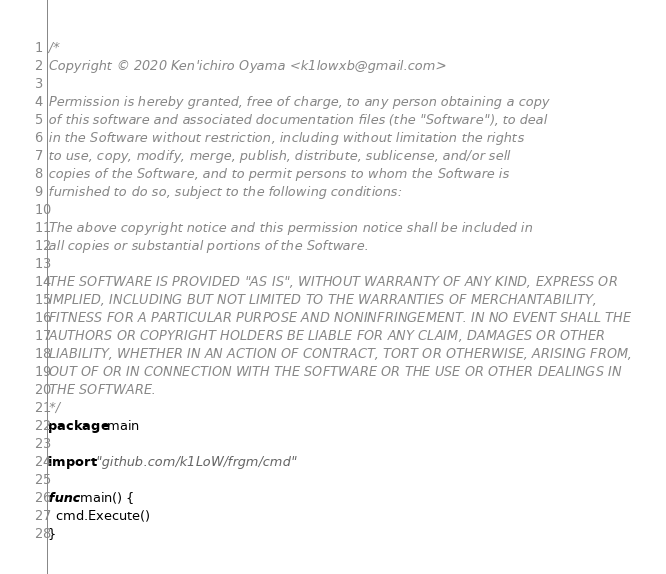Convert code to text. <code><loc_0><loc_0><loc_500><loc_500><_Go_>/*
Copyright © 2020 Ken'ichiro Oyama <k1lowxb@gmail.com>

Permission is hereby granted, free of charge, to any person obtaining a copy
of this software and associated documentation files (the "Software"), to deal
in the Software without restriction, including without limitation the rights
to use, copy, modify, merge, publish, distribute, sublicense, and/or sell
copies of the Software, and to permit persons to whom the Software is
furnished to do so, subject to the following conditions:

The above copyright notice and this permission notice shall be included in
all copies or substantial portions of the Software.

THE SOFTWARE IS PROVIDED "AS IS", WITHOUT WARRANTY OF ANY KIND, EXPRESS OR
IMPLIED, INCLUDING BUT NOT LIMITED TO THE WARRANTIES OF MERCHANTABILITY,
FITNESS FOR A PARTICULAR PURPOSE AND NONINFRINGEMENT. IN NO EVENT SHALL THE
AUTHORS OR COPYRIGHT HOLDERS BE LIABLE FOR ANY CLAIM, DAMAGES OR OTHER
LIABILITY, WHETHER IN AN ACTION OF CONTRACT, TORT OR OTHERWISE, ARISING FROM,
OUT OF OR IN CONNECTION WITH THE SOFTWARE OR THE USE OR OTHER DEALINGS IN
THE SOFTWARE.
*/
package main

import "github.com/k1LoW/frgm/cmd"

func main() {
  cmd.Execute()
}
</code> 